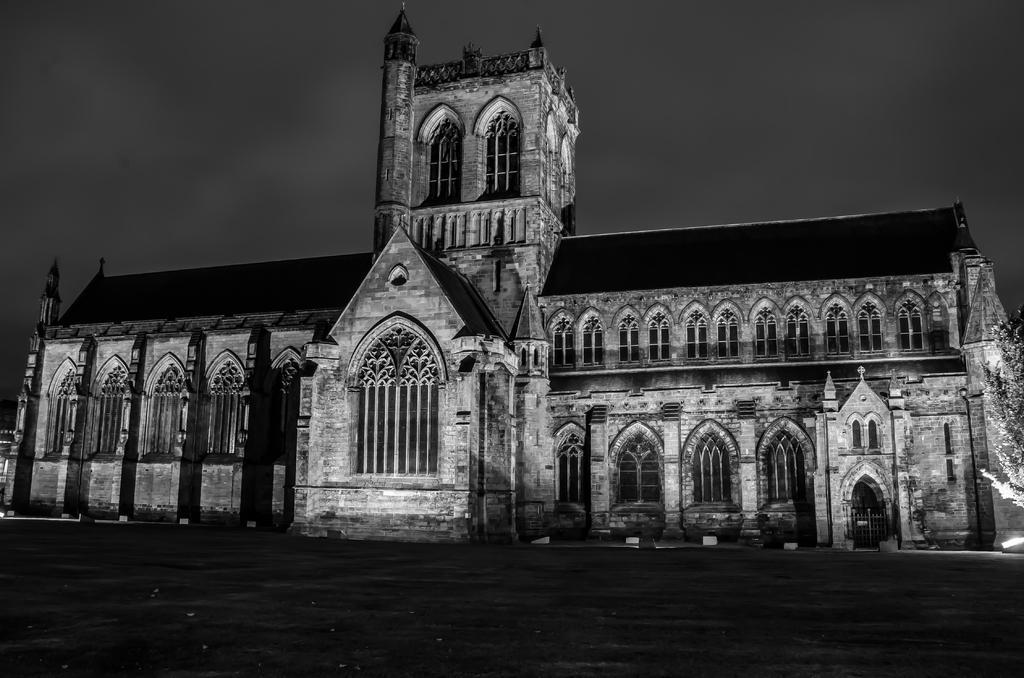Can you describe this image briefly? In this picture we can see the ground, tree, building with windows and in the background we can see the sky. 